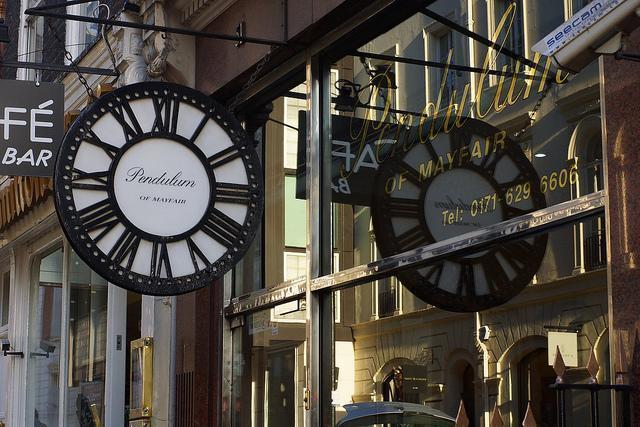How many clocks can you see?
Give a very brief answer. 2. 